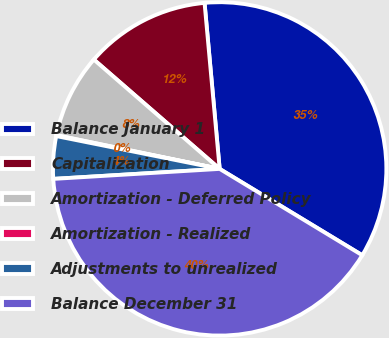Convert chart to OTSL. <chart><loc_0><loc_0><loc_500><loc_500><pie_chart><fcel>Balance January 1<fcel>Capitalization<fcel>Amortization - Deferred Policy<fcel>Amortization - Realized<fcel>Adjustments to unrealized<fcel>Balance December 31<nl><fcel>35.11%<fcel>12.17%<fcel>8.14%<fcel>0.09%<fcel>4.11%<fcel>40.38%<nl></chart> 